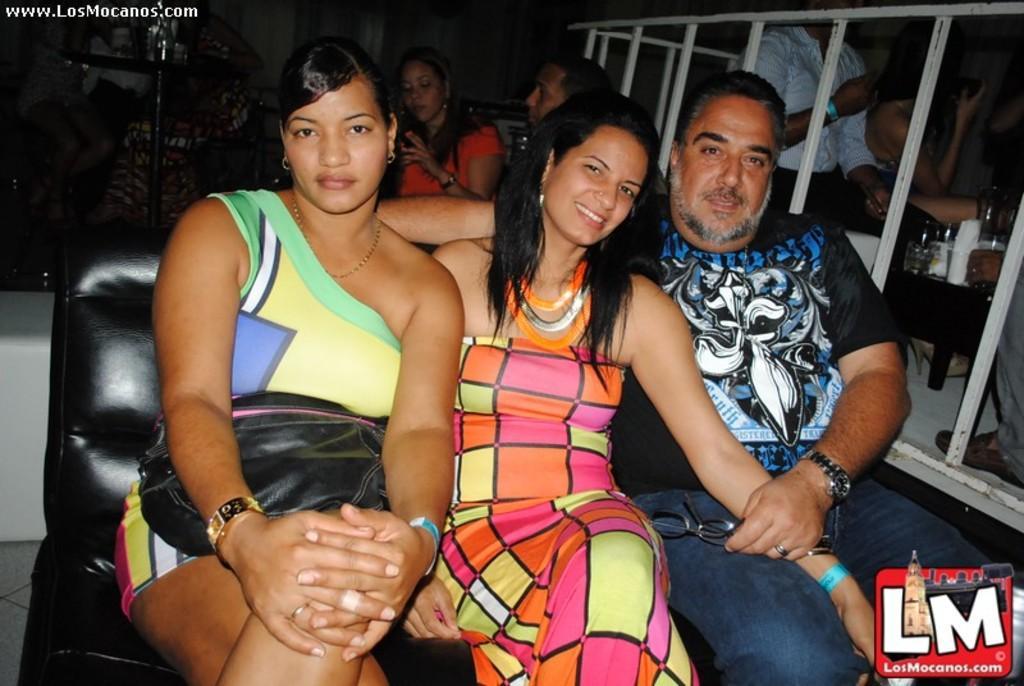Please provide a concise description of this image. In this image we can see three people sitting on a sofa. In that a man is holding the glasses. On the right side we can see a group of people sitting beside a table containing a jar, bottles and some tissue papers on it. 